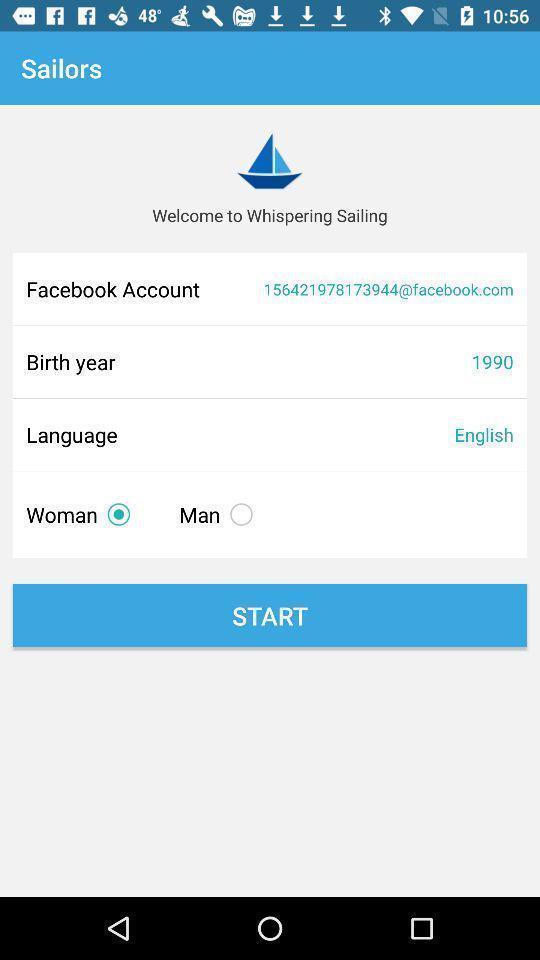Describe the key features of this screenshot. Welcome page of messaging app. 